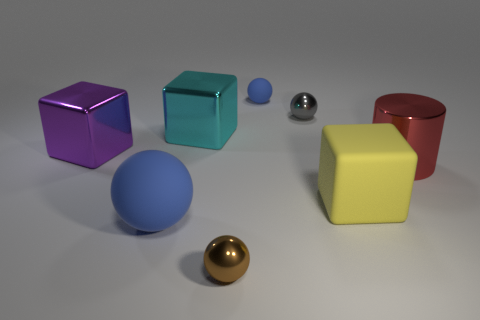Subtract all red cubes. How many blue spheres are left? 2 Subtract all small balls. How many balls are left? 1 Subtract all gray balls. How many balls are left? 3 Subtract 1 blocks. How many blocks are left? 2 Add 1 yellow matte things. How many objects exist? 9 Subtract all gray balls. Subtract all cyan cubes. How many balls are left? 3 Subtract all cylinders. How many objects are left? 7 Subtract all cylinders. Subtract all cyan things. How many objects are left? 6 Add 3 big matte objects. How many big matte objects are left? 5 Add 5 large brown rubber blocks. How many large brown rubber blocks exist? 5 